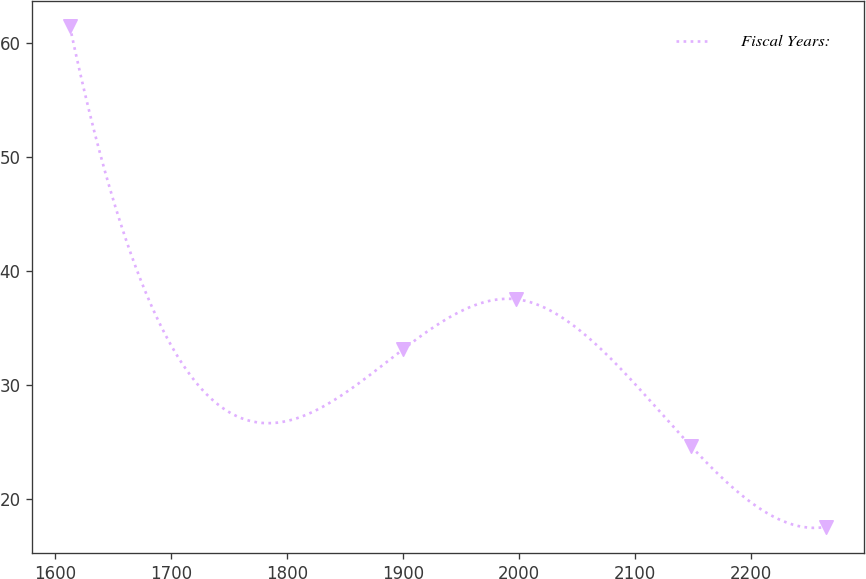Convert chart to OTSL. <chart><loc_0><loc_0><loc_500><loc_500><line_chart><ecel><fcel>Fiscal Years:<nl><fcel>1612.83<fcel>61.49<nl><fcel>1900.05<fcel>33.15<nl><fcel>1997.42<fcel>37.54<nl><fcel>2148.39<fcel>24.61<nl><fcel>2264.45<fcel>17.55<nl></chart> 